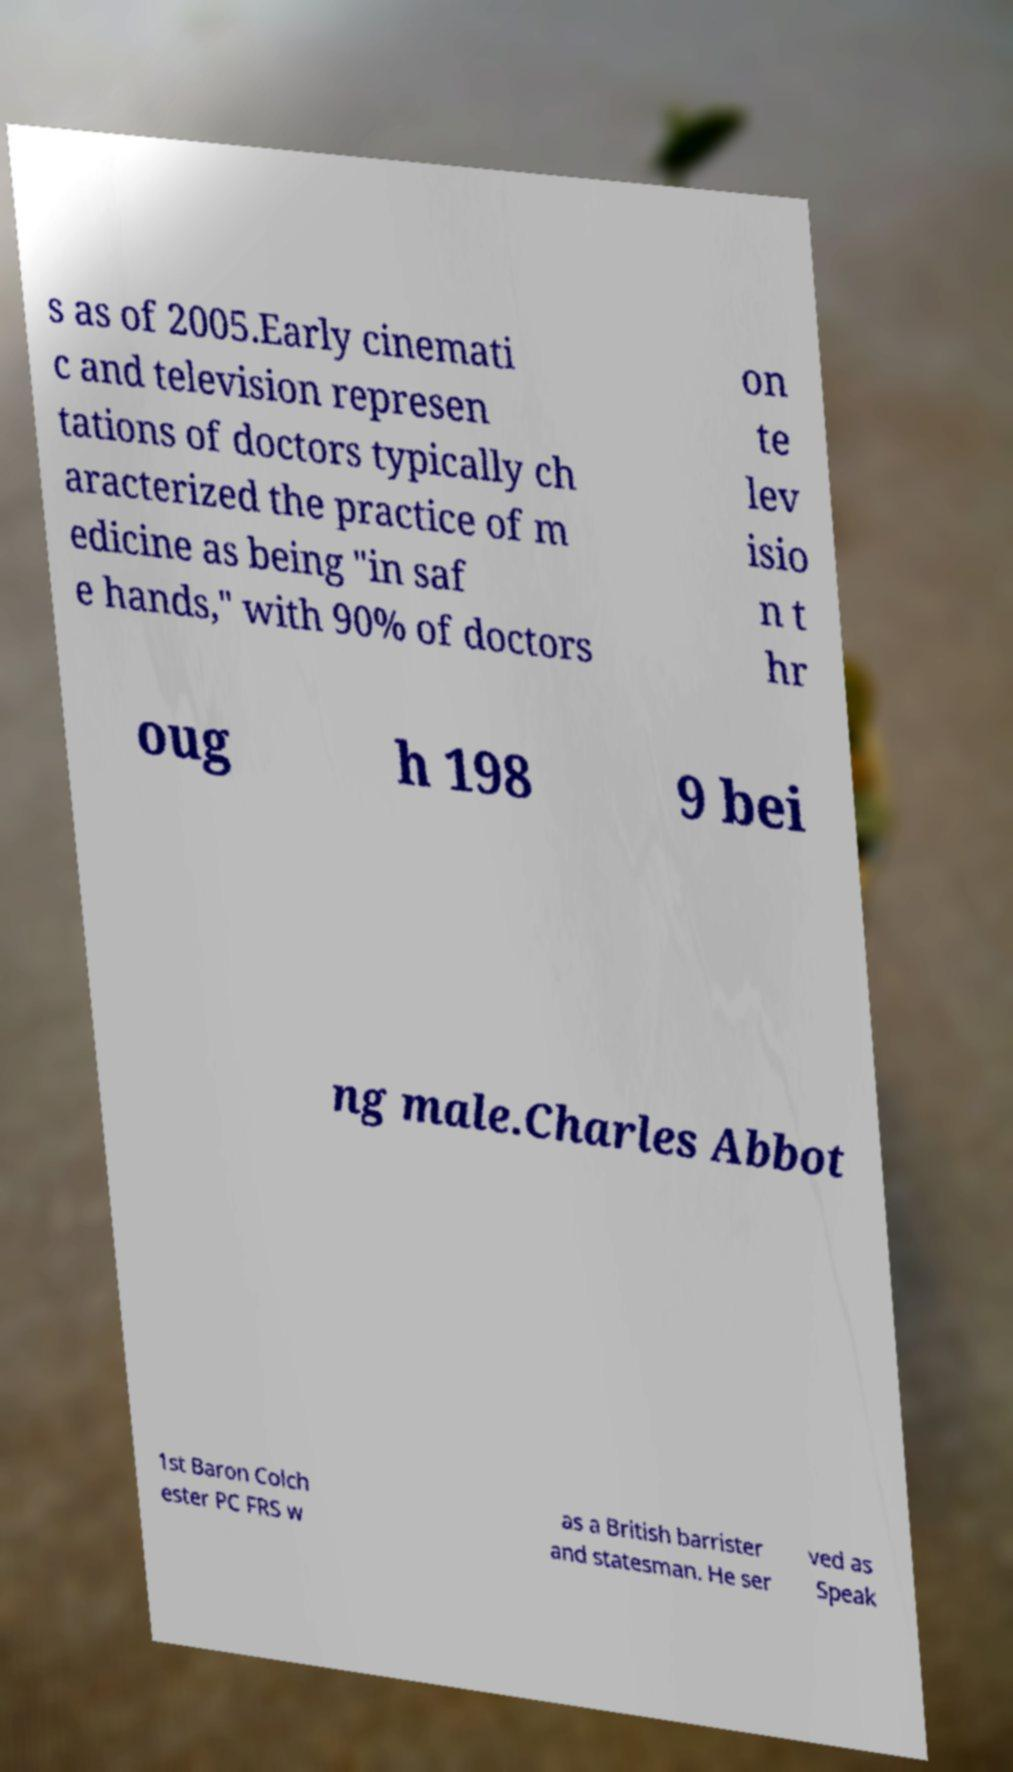What messages or text are displayed in this image? I need them in a readable, typed format. s as of 2005.Early cinemati c and television represen tations of doctors typically ch aracterized the practice of m edicine as being "in saf e hands," with 90% of doctors on te lev isio n t hr oug h 198 9 bei ng male.Charles Abbot 1st Baron Colch ester PC FRS w as a British barrister and statesman. He ser ved as Speak 